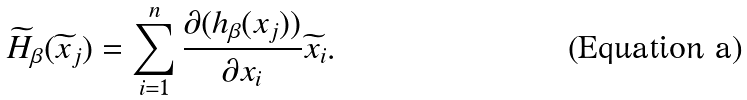Convert formula to latex. <formula><loc_0><loc_0><loc_500><loc_500>\widetilde { H } _ { \beta } ( \widetilde { x } _ { j } ) = \sum _ { i = 1 } ^ { n } \frac { \partial ( h _ { \beta } ( x _ { j } ) ) } { \partial x _ { i } } \widetilde { x } _ { i } .</formula> 